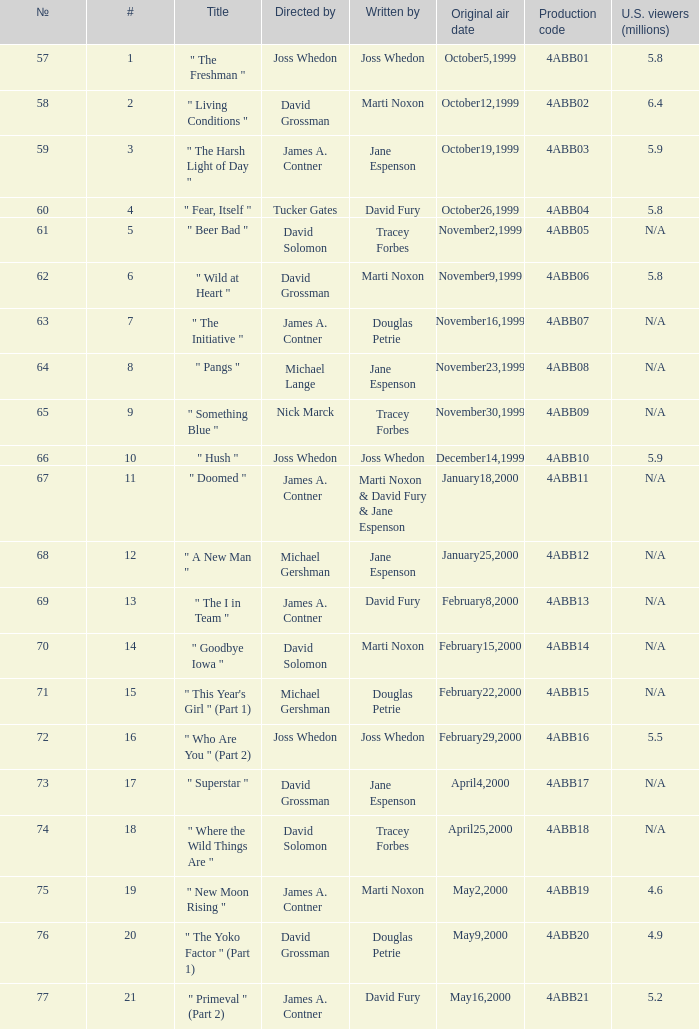Parse the table in full. {'header': ['№', '#', 'Title', 'Directed by', 'Written by', 'Original air date', 'Production code', 'U.S. viewers (millions)'], 'rows': [['57', '1', '" The Freshman "', 'Joss Whedon', 'Joss Whedon', 'October5,1999', '4ABB01', '5.8'], ['58', '2', '" Living Conditions "', 'David Grossman', 'Marti Noxon', 'October12,1999', '4ABB02', '6.4'], ['59', '3', '" The Harsh Light of Day "', 'James A. Contner', 'Jane Espenson', 'October19,1999', '4ABB03', '5.9'], ['60', '4', '" Fear, Itself "', 'Tucker Gates', 'David Fury', 'October26,1999', '4ABB04', '5.8'], ['61', '5', '" Beer Bad "', 'David Solomon', 'Tracey Forbes', 'November2,1999', '4ABB05', 'N/A'], ['62', '6', '" Wild at Heart "', 'David Grossman', 'Marti Noxon', 'November9,1999', '4ABB06', '5.8'], ['63', '7', '" The Initiative "', 'James A. Contner', 'Douglas Petrie', 'November16,1999', '4ABB07', 'N/A'], ['64', '8', '" Pangs "', 'Michael Lange', 'Jane Espenson', 'November23,1999', '4ABB08', 'N/A'], ['65', '9', '" Something Blue "', 'Nick Marck', 'Tracey Forbes', 'November30,1999', '4ABB09', 'N/A'], ['66', '10', '" Hush "', 'Joss Whedon', 'Joss Whedon', 'December14,1999', '4ABB10', '5.9'], ['67', '11', '" Doomed "', 'James A. Contner', 'Marti Noxon & David Fury & Jane Espenson', 'January18,2000', '4ABB11', 'N/A'], ['68', '12', '" A New Man "', 'Michael Gershman', 'Jane Espenson', 'January25,2000', '4ABB12', 'N/A'], ['69', '13', '" The I in Team "', 'James A. Contner', 'David Fury', 'February8,2000', '4ABB13', 'N/A'], ['70', '14', '" Goodbye Iowa "', 'David Solomon', 'Marti Noxon', 'February15,2000', '4ABB14', 'N/A'], ['71', '15', '" This Year\'s Girl " (Part 1)', 'Michael Gershman', 'Douglas Petrie', 'February22,2000', '4ABB15', 'N/A'], ['72', '16', '" Who Are You " (Part 2)', 'Joss Whedon', 'Joss Whedon', 'February29,2000', '4ABB16', '5.5'], ['73', '17', '" Superstar "', 'David Grossman', 'Jane Espenson', 'April4,2000', '4ABB17', 'N/A'], ['74', '18', '" Where the Wild Things Are "', 'David Solomon', 'Tracey Forbes', 'April25,2000', '4ABB18', 'N/A'], ['75', '19', '" New Moon Rising "', 'James A. Contner', 'Marti Noxon', 'May2,2000', '4ABB19', '4.6'], ['76', '20', '" The Yoko Factor " (Part 1)', 'David Grossman', 'Douglas Petrie', 'May9,2000', '4ABB20', '4.9'], ['77', '21', '" Primeval " (Part 2)', 'James A. Contner', 'David Fury', 'May16,2000', '4ABB21', '5.2']]} Who wrote the episode which was directed by Nick Marck? Tracey Forbes. 